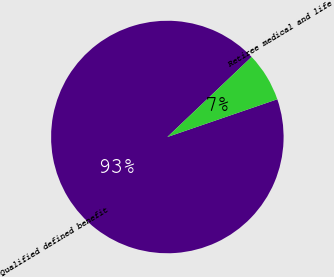Convert chart to OTSL. <chart><loc_0><loc_0><loc_500><loc_500><pie_chart><fcel>Qualified defined benefit<fcel>Retiree medical and life<nl><fcel>93.17%<fcel>6.83%<nl></chart> 